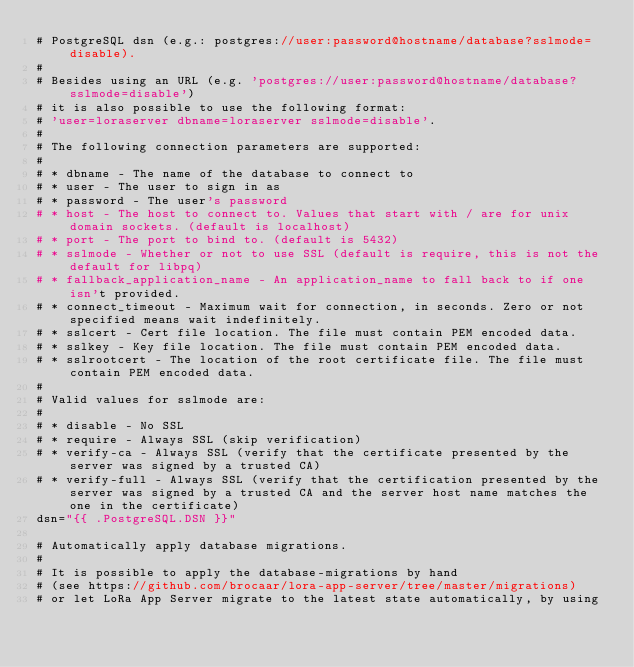Convert code to text. <code><loc_0><loc_0><loc_500><loc_500><_Go_># PostgreSQL dsn (e.g.: postgres://user:password@hostname/database?sslmode=disable).
#
# Besides using an URL (e.g. 'postgres://user:password@hostname/database?sslmode=disable')
# it is also possible to use the following format:
# 'user=loraserver dbname=loraserver sslmode=disable'.
#
# The following connection parameters are supported:
#
# * dbname - The name of the database to connect to
# * user - The user to sign in as
# * password - The user's password
# * host - The host to connect to. Values that start with / are for unix domain sockets. (default is localhost)
# * port - The port to bind to. (default is 5432)
# * sslmode - Whether or not to use SSL (default is require, this is not the default for libpq)
# * fallback_application_name - An application_name to fall back to if one isn't provided.
# * connect_timeout - Maximum wait for connection, in seconds. Zero or not specified means wait indefinitely.
# * sslcert - Cert file location. The file must contain PEM encoded data.
# * sslkey - Key file location. The file must contain PEM encoded data.
# * sslrootcert - The location of the root certificate file. The file must contain PEM encoded data.
#
# Valid values for sslmode are:
#
# * disable - No SSL
# * require - Always SSL (skip verification)
# * verify-ca - Always SSL (verify that the certificate presented by the server was signed by a trusted CA)
# * verify-full - Always SSL (verify that the certification presented by the server was signed by a trusted CA and the server host name matches the one in the certificate)
dsn="{{ .PostgreSQL.DSN }}"

# Automatically apply database migrations.
#
# It is possible to apply the database-migrations by hand
# (see https://github.com/brocaar/lora-app-server/tree/master/migrations)
# or let LoRa App Server migrate to the latest state automatically, by using</code> 